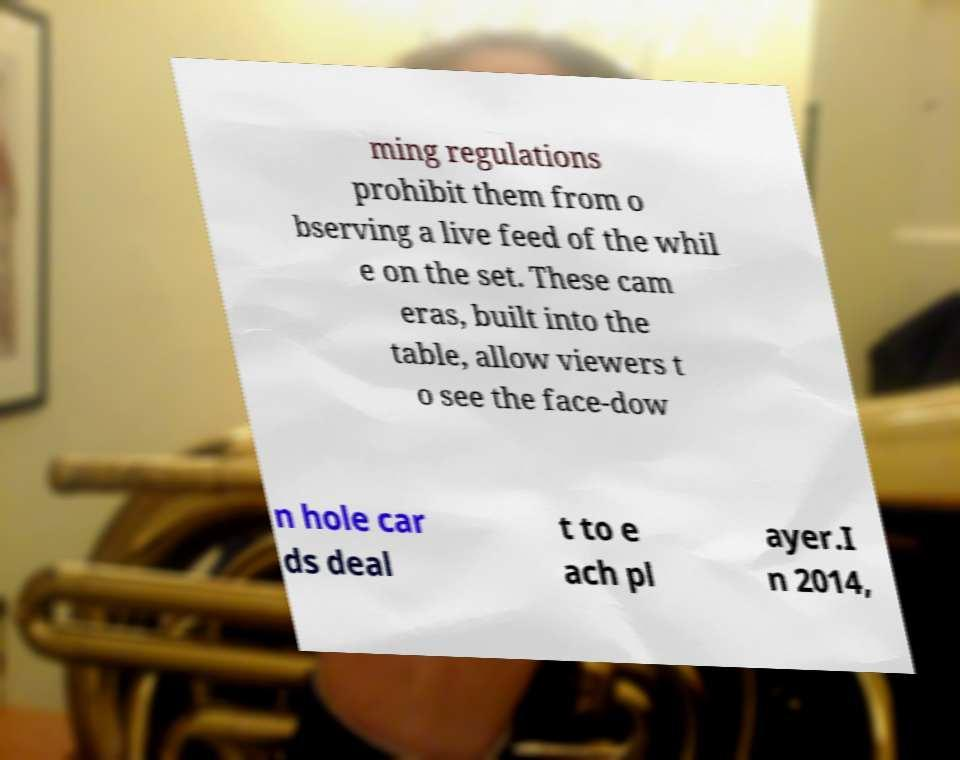Could you assist in decoding the text presented in this image and type it out clearly? ming regulations prohibit them from o bserving a live feed of the whil e on the set. These cam eras, built into the table, allow viewers t o see the face-dow n hole car ds deal t to e ach pl ayer.I n 2014, 